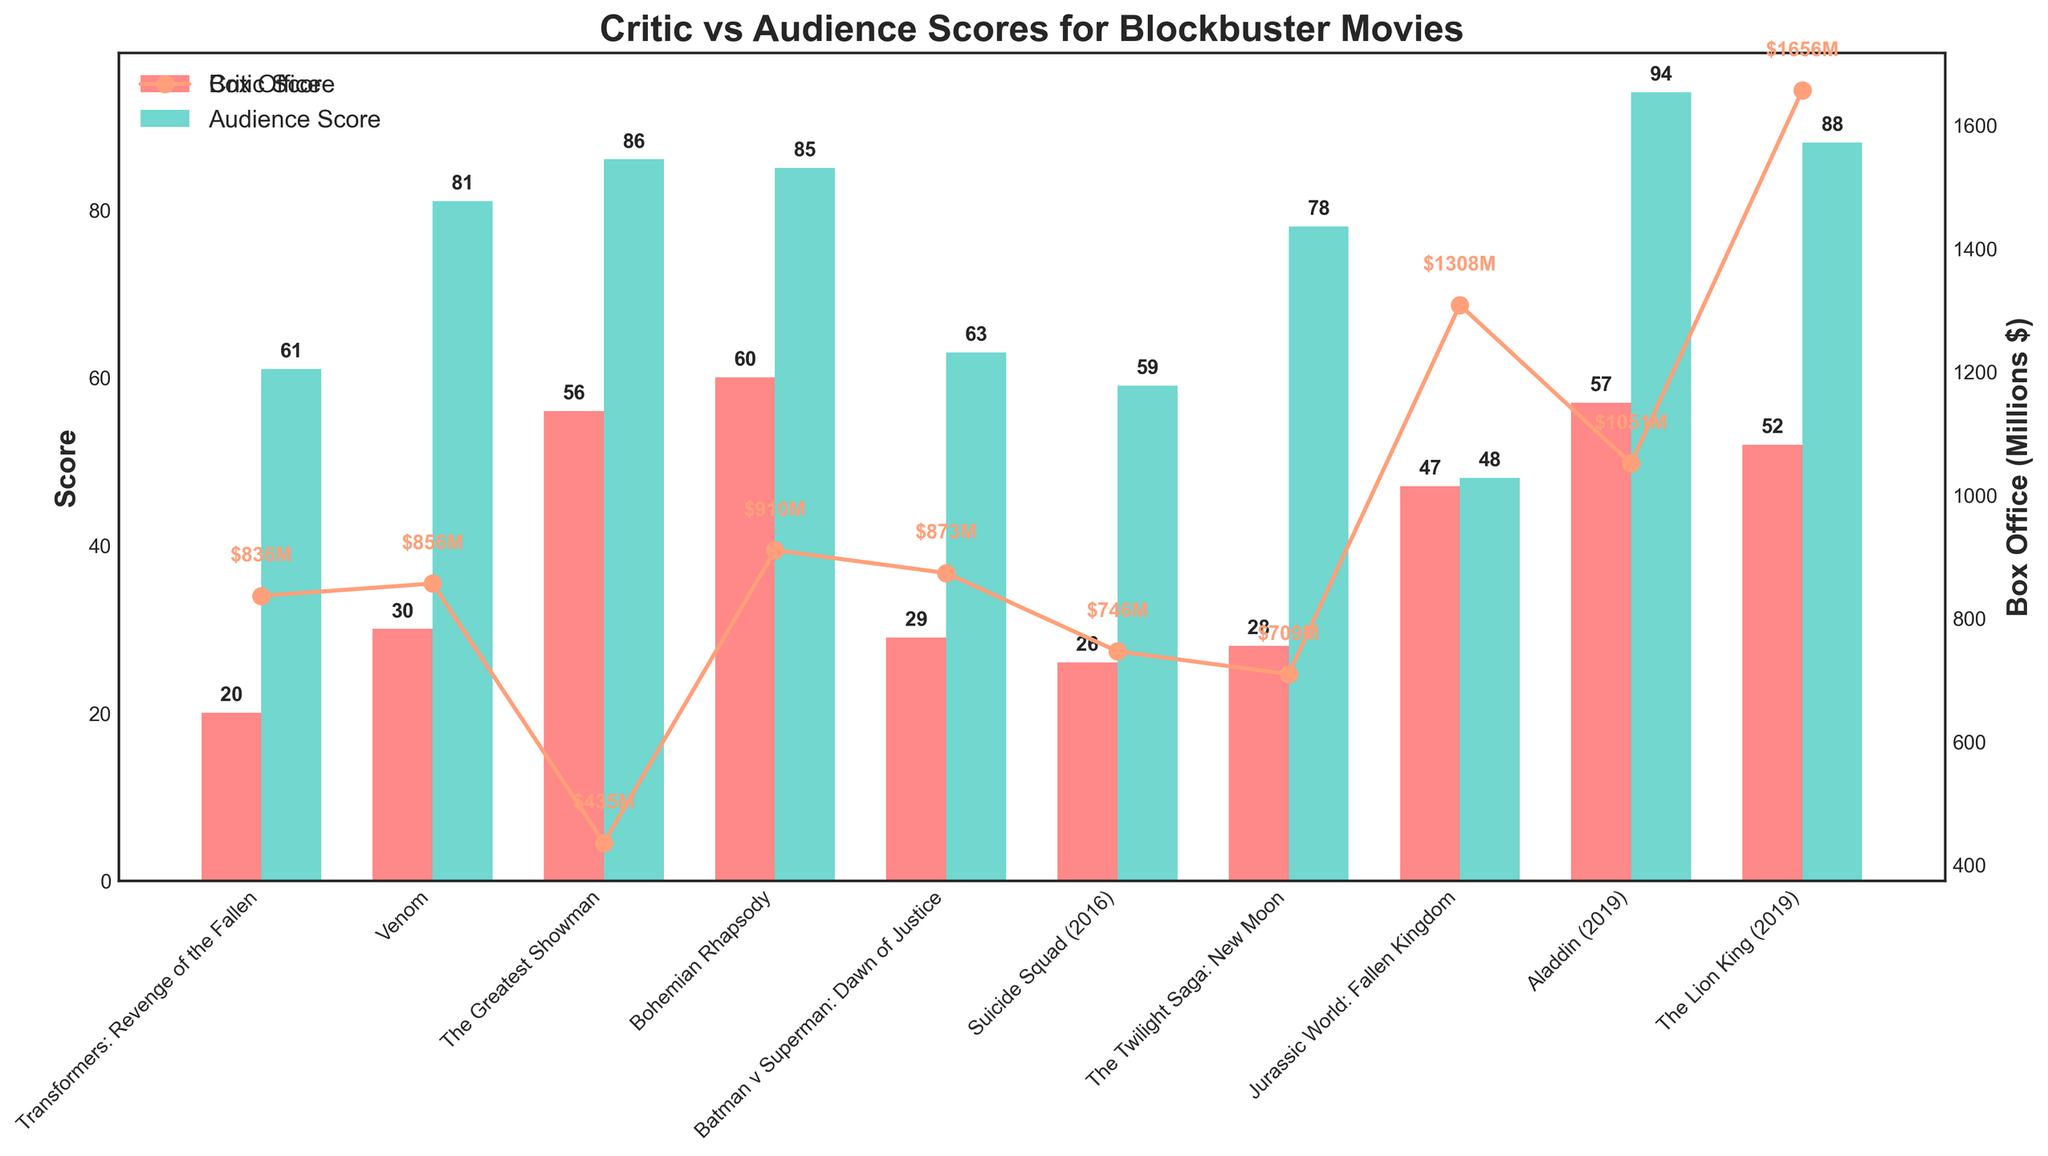What's the average audience score of the top three movies in terms of box office revenue? The three movies with the highest box office revenues are "The Lion King (2019)" ($1656M), "Jurassic World: Fallen Kingdom" ($1308M), and "Aladdin (2019)" ($1051M). Their audience scores are 88, 48, and 94 respectively. The average is (88 + 48 + 94) / 3 = 76.67
Answer: 76.67 Which movie has the largest gap between critic score and audience score? To determine the gap, subtract the critic score from the audience score for each movie. The largest gap is for "Venom" where the difference is 81 - 30 = 51.
Answer: Venom How many movies have a higher audience score than critic score? Compare the audience score and critic score for each movie. All the movies except "Jurassic World: Fallen Kingdom" have higher audience scores than critic scores. Count these movies to get the total.
Answer: 9 Which movie has the smallest box office revenue, and what is it? Observe the heights of the box office markers and read the values. "The Greatest Showman" has the smallest box office revenue at $435M.
Answer: The Greatest Showman, $435M Compare the box office revenue of "Batman v Superman: Dawn of Justice" and "Suicide Squad (2016)." Which one earned more? Look at the box office values from the figure. "Batman v Superman: Dawn of Justice" has $873M, while "Suicide Squad (2016)" has $746M. Therefore, "Batman v Superman" earned more.
Answer: Batman v Superman: Dawn of Justice What is the total box office revenue for movies with a critic score below 30? Identify movies with critic scores below 30 and sum their box office revenues: "Transformers: Revenge of the Fallen" ($836M), "Venom" ($856M), "Batman v Superman: Dawn of Justice" ($873M), "Suicide Squad (2016)" ($746M), and "The Twilight Saga: New Moon" ($709M). The total is 836 + 856 + 873 + 746 + 709 = 4020.
Answer: $4020M Are there any movies where the critic and audience scores are equal? Compare critic and audience scores for each movie. The only instance is "Jurassic World: Fallen Kingdom," where both scores are 48.
Answer: Yes, Jurassic World: Fallen Kingdom Among the movies with an audience score above 80, which one has the lowest box office revenue? Identify movies with an audience score above 80: "Venom," "The Greatest Showman," "Bohemian Rhapsody," "Aladdin (2019)," and "The Lion King (2019)." Among these, "The Greatest Showman" has the lowest box office revenue at $435M.
Answer: The Greatest Showman What is the average critic score for the movies listed? Sum all critic scores: 20 + 30 + 56 + 60 + 29 + 26 + 28 + 47 + 57 + 52 = 405. Divide by 10 (the number of movies) to get the average: 405 / 10 = 40.5.
Answer: 40.5 